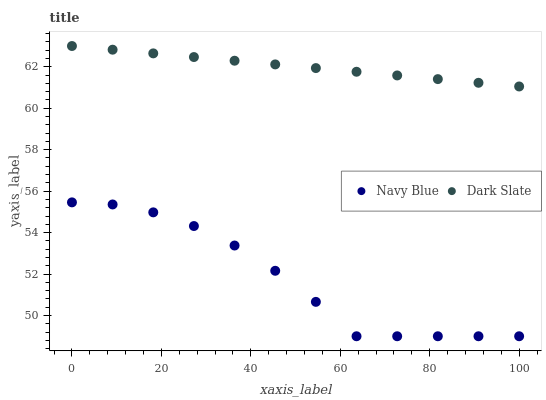Does Navy Blue have the minimum area under the curve?
Answer yes or no. Yes. Does Dark Slate have the maximum area under the curve?
Answer yes or no. Yes. Does Dark Slate have the minimum area under the curve?
Answer yes or no. No. Is Dark Slate the smoothest?
Answer yes or no. Yes. Is Navy Blue the roughest?
Answer yes or no. Yes. Is Dark Slate the roughest?
Answer yes or no. No. Does Navy Blue have the lowest value?
Answer yes or no. Yes. Does Dark Slate have the lowest value?
Answer yes or no. No. Does Dark Slate have the highest value?
Answer yes or no. Yes. Is Navy Blue less than Dark Slate?
Answer yes or no. Yes. Is Dark Slate greater than Navy Blue?
Answer yes or no. Yes. Does Navy Blue intersect Dark Slate?
Answer yes or no. No. 